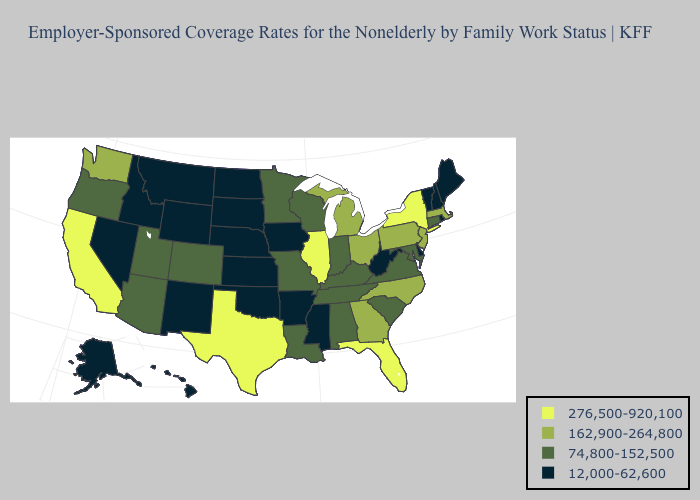What is the highest value in the USA?
Answer briefly. 276,500-920,100. What is the value of Kansas?
Quick response, please. 12,000-62,600. Among the states that border North Dakota , does Minnesota have the highest value?
Quick response, please. Yes. Name the states that have a value in the range 162,900-264,800?
Answer briefly. Georgia, Massachusetts, Michigan, New Jersey, North Carolina, Ohio, Pennsylvania, Washington. Does Florida have the highest value in the USA?
Be succinct. Yes. Name the states that have a value in the range 12,000-62,600?
Quick response, please. Alaska, Arkansas, Delaware, Hawaii, Idaho, Iowa, Kansas, Maine, Mississippi, Montana, Nebraska, Nevada, New Hampshire, New Mexico, North Dakota, Oklahoma, Rhode Island, South Dakota, Vermont, West Virginia, Wyoming. Which states have the highest value in the USA?
Answer briefly. California, Florida, Illinois, New York, Texas. Which states have the lowest value in the USA?
Concise answer only. Alaska, Arkansas, Delaware, Hawaii, Idaho, Iowa, Kansas, Maine, Mississippi, Montana, Nebraska, Nevada, New Hampshire, New Mexico, North Dakota, Oklahoma, Rhode Island, South Dakota, Vermont, West Virginia, Wyoming. Is the legend a continuous bar?
Write a very short answer. No. What is the highest value in states that border Missouri?
Short answer required. 276,500-920,100. Name the states that have a value in the range 162,900-264,800?
Write a very short answer. Georgia, Massachusetts, Michigan, New Jersey, North Carolina, Ohio, Pennsylvania, Washington. Among the states that border Wyoming , does South Dakota have the lowest value?
Short answer required. Yes. What is the highest value in the USA?
Keep it brief. 276,500-920,100. How many symbols are there in the legend?
Quick response, please. 4. Does the first symbol in the legend represent the smallest category?
Short answer required. No. 